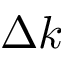Convert formula to latex. <formula><loc_0><loc_0><loc_500><loc_500>\Delta k</formula> 